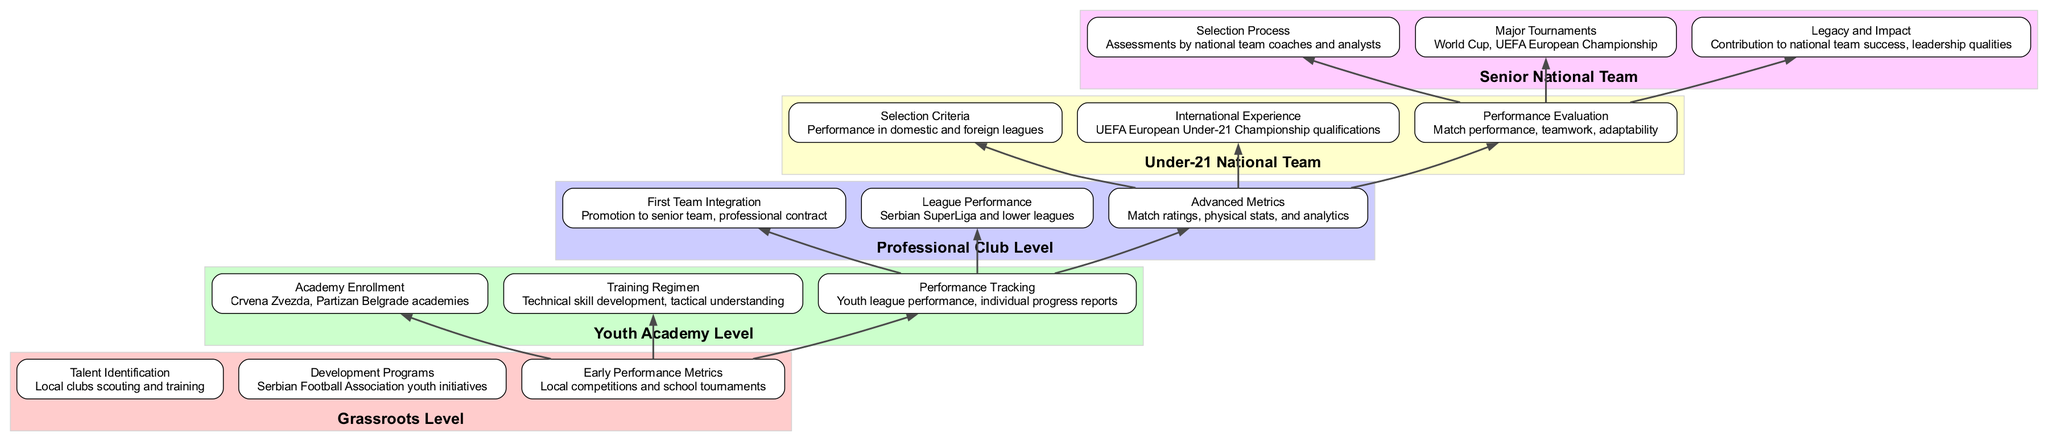What is the first step in Player Performance Evaluation? The evaluation process begins at the Grassroots Level, specifically with Talent Identification, which involves local clubs scouting and training young players.
Answer: Talent Identification Which professional leagues are considered for player performance? Players are evaluated based on their performance in the Serbian SuperLiga and lower leagues, which are included in the Professional Club Level.
Answer: Serbian SuperLiga and lower leagues What does the selection criteria for the Under-21 National Team focus on? The selection criteria for the Under-21 National Team focus on the player's performance in domestic and foreign leagues, which is essential for their evaluation and selection process.
Answer: Performance in domestic and foreign leagues How does the Senior National Team assess players? Players for the Senior National Team are assessed by national team coaches and analysts, indicating a structured evaluation process based on previous performance and potential contributions.
Answer: Assessments by national team coaches and analysts What development programs are available at the Grassroots Level? The Grassroots Level offers Development Programs through Serbian Football Association youth initiatives, aimed at nurturing young talent from an early stage.
Answer: Serbian Football Association youth initiatives Which level of evaluation includes international experience? International Experience is considered during the evaluation for the Under-21 National Team, highlighting the importance of exposure to international competitions for young talents.
Answer: Under-21 National Team What is a performance tracking method used at the Youth Academy Level? At the Youth Academy Level, performance tracking is achieved through evaluating youth league performance and individual progress reports, ensuring that player development is continually assessed.
Answer: Youth league performance, individual progress reports Which major tournaments do players aim to participate in at the Senior National Team Level? Players aim to participate in major tournaments like the World Cup and UEFA European Championship, which are critical for representing the national team on an international stage.
Answer: World Cup, UEFA European Championship What is the last step in the evaluation flow? The last step in the evaluation flow is the Legacy and Impact of a player within the Senior National Team, which assesses their overall contribution and leadership qualities.
Answer: Contribution to national team success, leadership qualities 